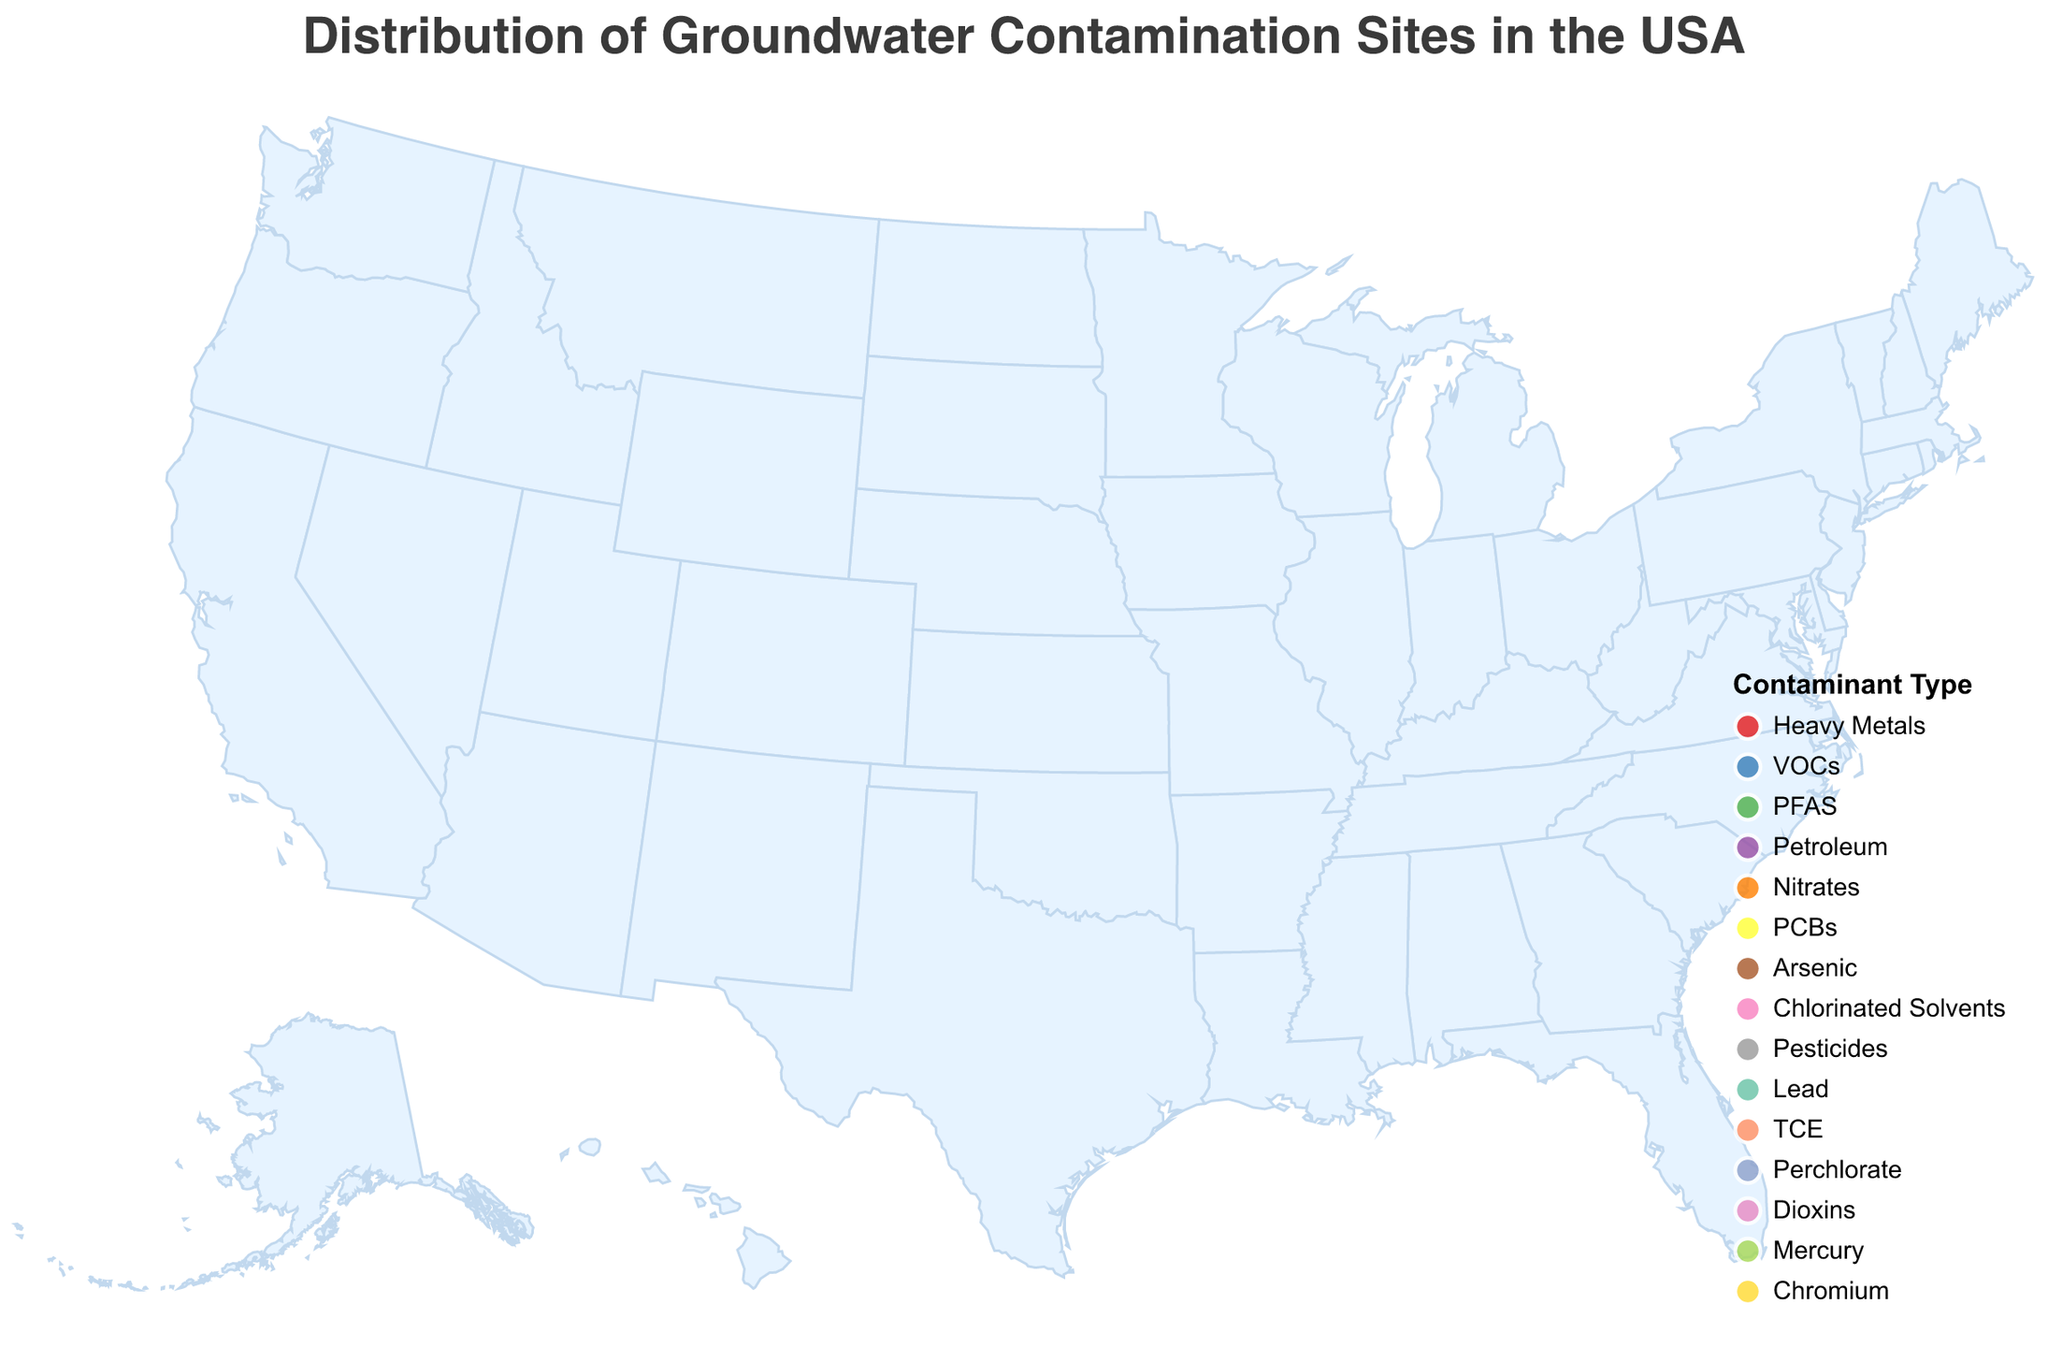What is the most common type of groundwater contaminant in the figure? To answer this question, we need to look at the color legend associated with contamination types and then count the number of sites for each contaminant type based on the colored circles. The most common type will be the one with the most occurrences.
Answer: Heavy Metals, VOCs, PFAS, Arsenic, Lead, and TCE each occur equally Which location has the highest severity level? The severity level is represented by the size of the circles. By finding the largest circles on the map and looking at the tooltip information, we can identify the locations with the highest severity level.
Answer: Chicago IL, Houston TX, and New York NY How many contamination sites have a severity level of 3? We need to count the number of circles on the map that have a size corresponding to a severity level of 3. We can also check the tooltip for verification.
Answer: 5 Which city has contamination from PFAS? By checking the color legend and matching with the circles on the geographic locations, we can find the contamination type. We then check the tooltip for specific information.
Answer: Chicago IL What types of contaminants are found in Texas? Look at the two geographic points in Texas (Dallas and Houston) and read the contamination type from the tooltip for each.
Answer: Petroleum and Arsenic Which location is affected by the lowest severity level of contamination? The smallest circles represent the lowest severity levels. By identifying those circles and checking the tooltip, we can determine the locations.
Answer: Dallas TX and Portland OR Compare the severity levels of contamination in Miami FL and Los Angeles CA. Which is higher? Check the size of the circles in Miami FL and Los Angeles CA and use the tooltip to read the severity levels. Compare the severity levels to find which is higher.
Answer: Los Angeles CA How does the number of contamination sites in the western half of the USA compare to those in the eastern half? First, determine the median longitude to split the country into western and eastern halves. Count the sites in each half based on their geographic positions on the map.
Answer: About even (7 west, 8 east) Which locations have a contaminant type that falls under "Heavy Metals"? Look at the color legend specific to "Heavy Metals" and match those colors to the circles on the map. Check the tooltip for specific locations.
Answer: Atlanta GA 